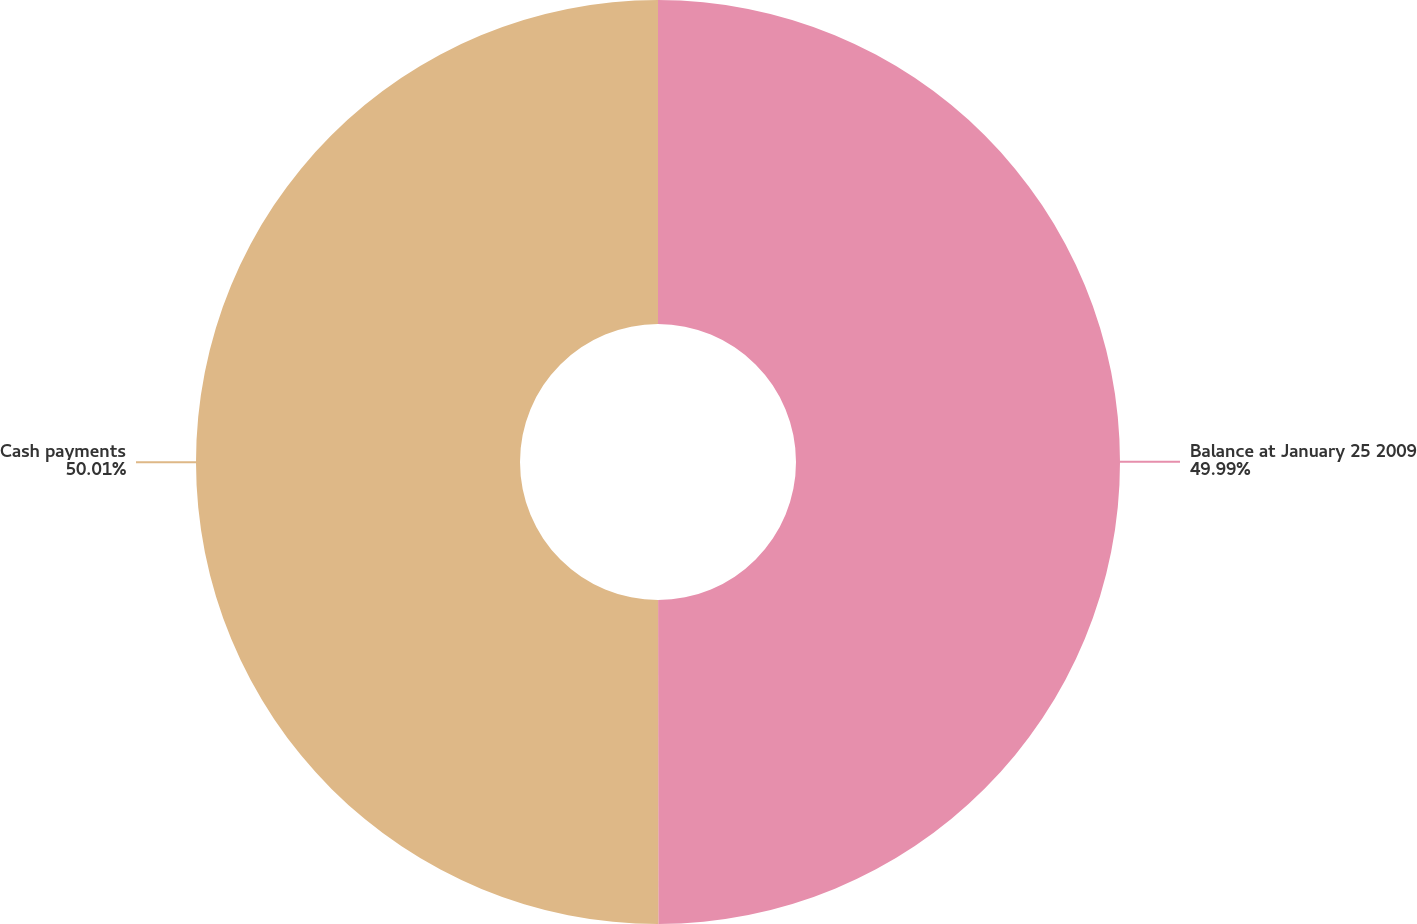<chart> <loc_0><loc_0><loc_500><loc_500><pie_chart><fcel>Balance at January 25 2009<fcel>Cash payments<nl><fcel>49.99%<fcel>50.01%<nl></chart> 